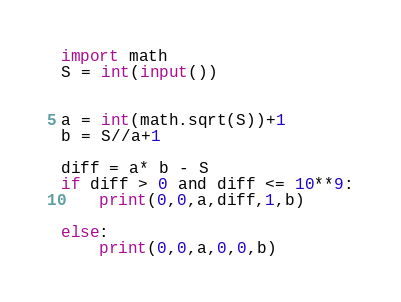<code> <loc_0><loc_0><loc_500><loc_500><_Python_>import math
S = int(input())


a = int(math.sqrt(S))+1
b = S//a+1

diff = a* b - S
if diff > 0 and diff <= 10**9:
    print(0,0,a,diff,1,b)
    
else:
    print(0,0,a,0,0,b)
</code> 